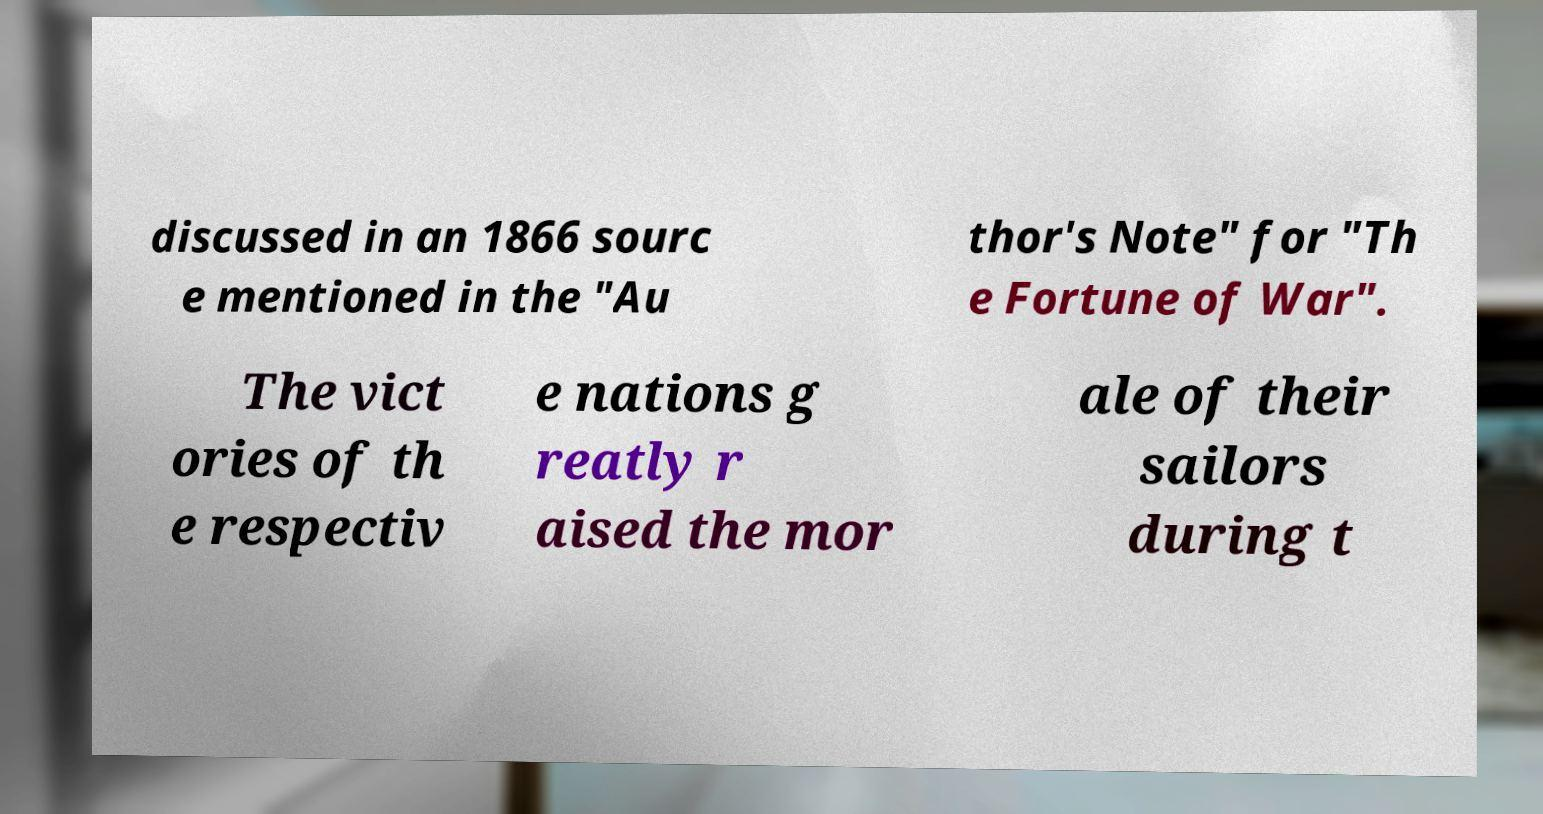Could you assist in decoding the text presented in this image and type it out clearly? discussed in an 1866 sourc e mentioned in the "Au thor's Note" for "Th e Fortune of War". The vict ories of th e respectiv e nations g reatly r aised the mor ale of their sailors during t 